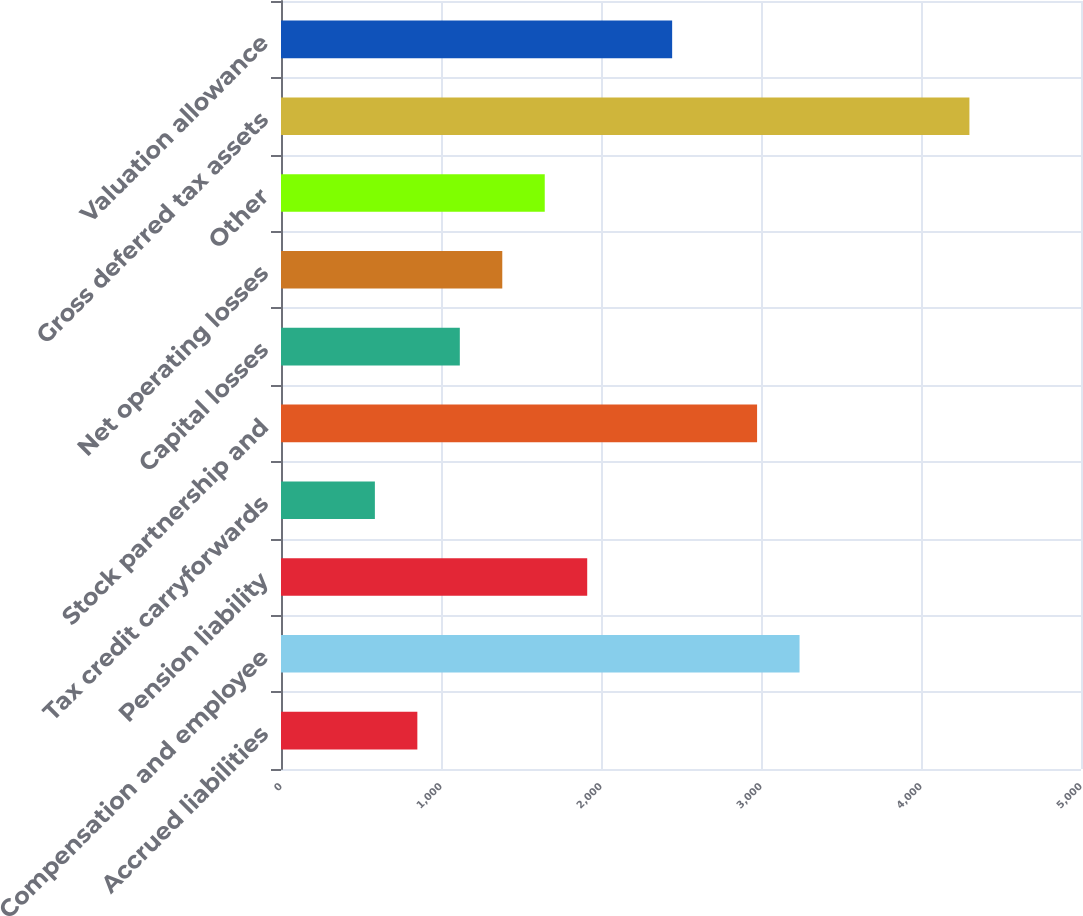Convert chart. <chart><loc_0><loc_0><loc_500><loc_500><bar_chart><fcel>Accrued liabilities<fcel>Compensation and employee<fcel>Pension liability<fcel>Tax credit carryforwards<fcel>Stock partnership and<fcel>Capital losses<fcel>Net operating losses<fcel>Other<fcel>Gross deferred tax assets<fcel>Valuation allowance<nl><fcel>852.16<fcel>3240.94<fcel>1913.84<fcel>586.74<fcel>2975.52<fcel>1117.58<fcel>1383<fcel>1648.42<fcel>4302.62<fcel>2444.68<nl></chart> 